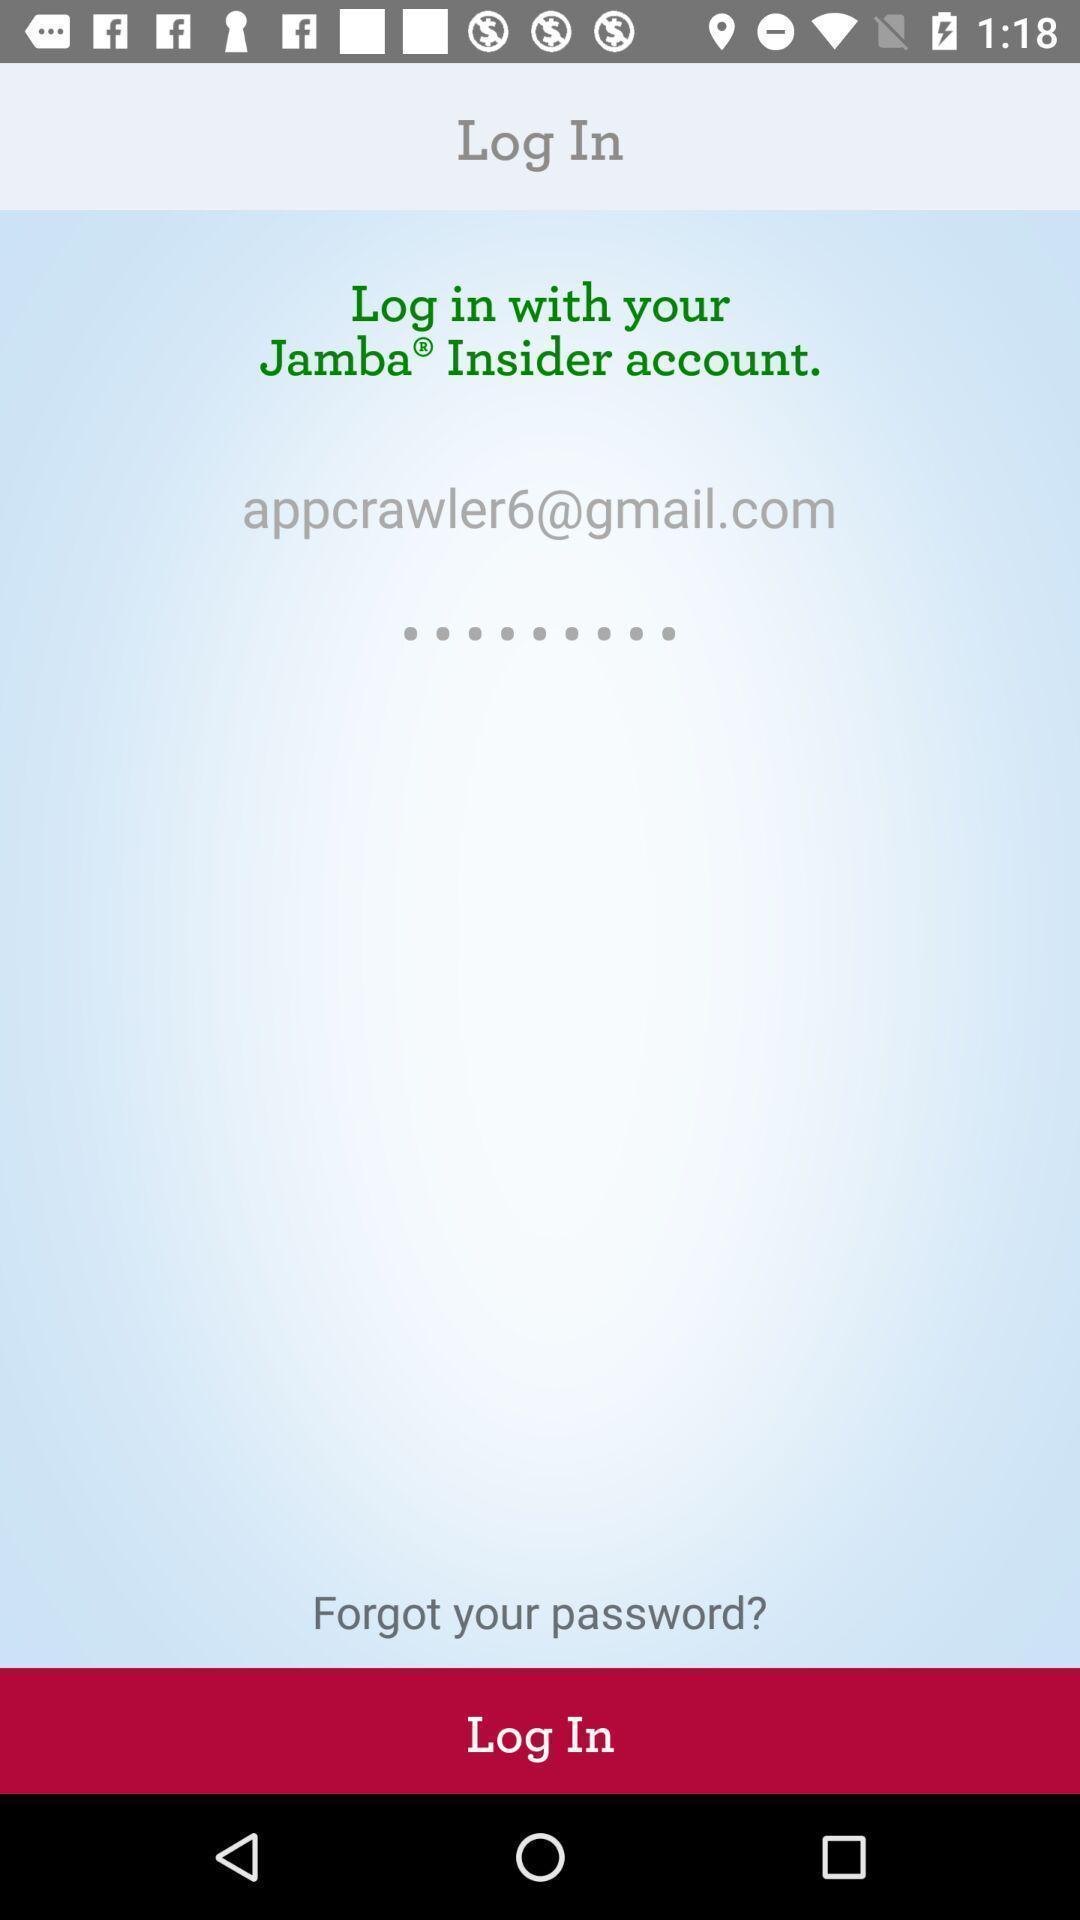Explain the elements present in this screenshot. Login page. 